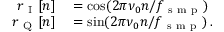Convert formula to latex. <formula><loc_0><loc_0><loc_500><loc_500>\begin{array} { r l } { r _ { I } [ n ] } & = \cos ( 2 \pi \nu _ { 0 } n / f _ { s m p } ) } \\ { r _ { Q } [ n ] } & = \sin ( 2 \pi \nu _ { 0 } n / f _ { s m p } ) \, . } \end{array}</formula> 